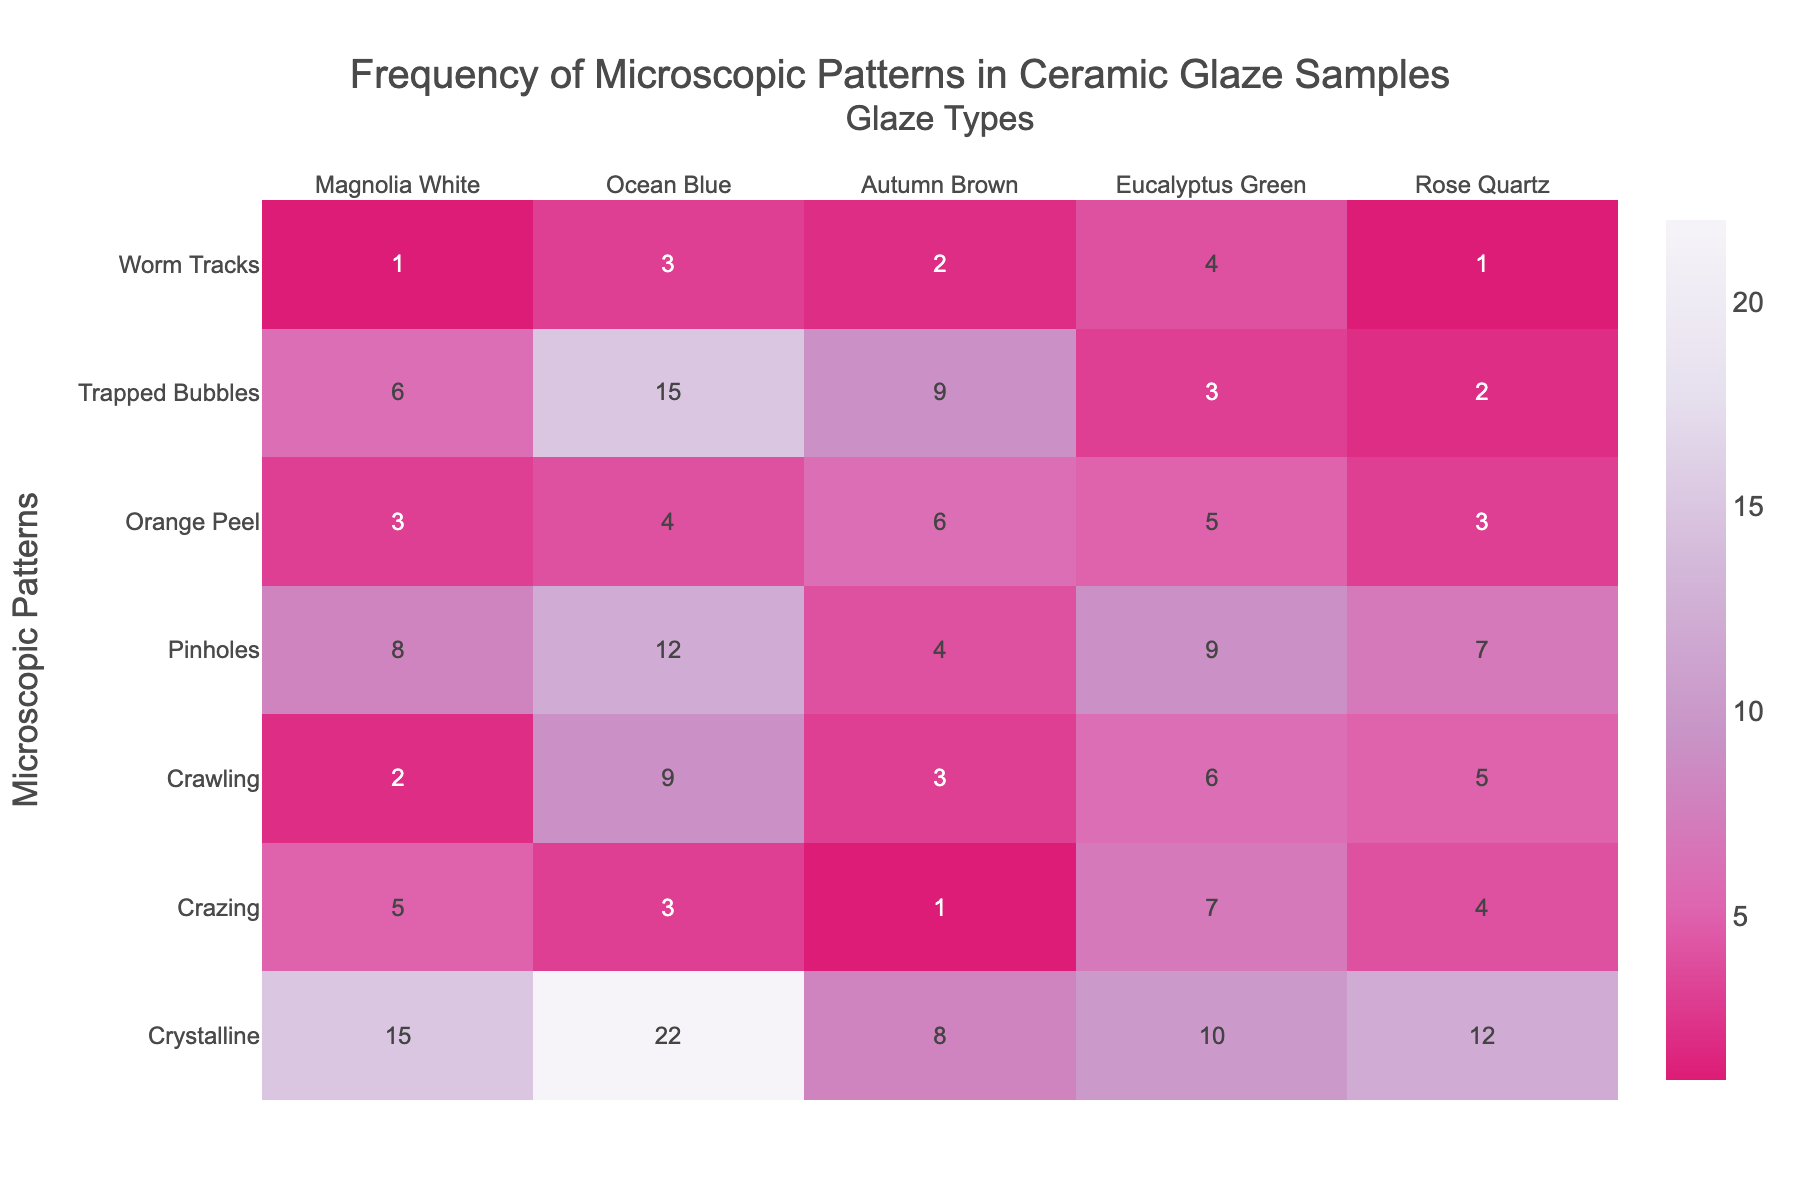Which glaze sample has the highest frequency of the Crystalline pattern? Look at the row labeled "Crystalline" and identify the column with the highest value. The highest value is 22, which is in the "Ocean Blue" column.
Answer: Ocean Blue What is the combined frequency of the Crawling pattern across all glaze samples? Sum the values in the "Crawling" row: 2 + 9 + 3 + 6 + 5 = 25.
Answer: 25 Which microscopic pattern appears the least frequently in the Eucalyptus Green glaze sample? Look at the column labeled "Eucalyptus Green" and identify the smallest value. The smallest value is 3 for "Trapped Bubbles".
Answer: Trapped Bubbles Of all the patterns, which one has the highest frequency in the Magnolia White glaze sample? Look at the column labeled "Magnolia White" and find the highest value. The highest value is 15 for "Crystalline".
Answer: Crystalline Which glaze sample shows no frequency of the Worm Tracks pattern? Look at the row labeled "Worm Tracks" and find any column with a zero value. There are no zero values in this row.
Answer: None How does the frequency of Pinholes in Magnolia White compare to Ocean Blue? Look at the row labeled "Pinholes" and compare the values in the "Magnolia White" and "Ocean Blue" columns. The values are 8 and 12, respectively.
Answer: Ocean Blue has more Is there any pattern that has the same frequency in both Magnolia White and Rose Quartz glaze samples? Compare the values in columns "Magnolia White" and "Rose Quartz" for each row. Only "Orange Peel" has the same value: 3.
Answer: Orange Peel What is the average frequency of Crazing across all glaze samples? Sum the values in the "Crazing" row and divide by the number of glaze types: (5 + 3 + 1 + 7 + 4) / 5 = 20 / 5 = 4.
Answer: 4 Which microscopic pattern has the second highest frequency in Ocean Blue glaze sample? Look at the column labeled "Ocean Blue" and identify the top two values. After 22 for "Crystalline", the next highest value is 15 for "Trapped Bubbles".
Answer: Trapped Bubbles 